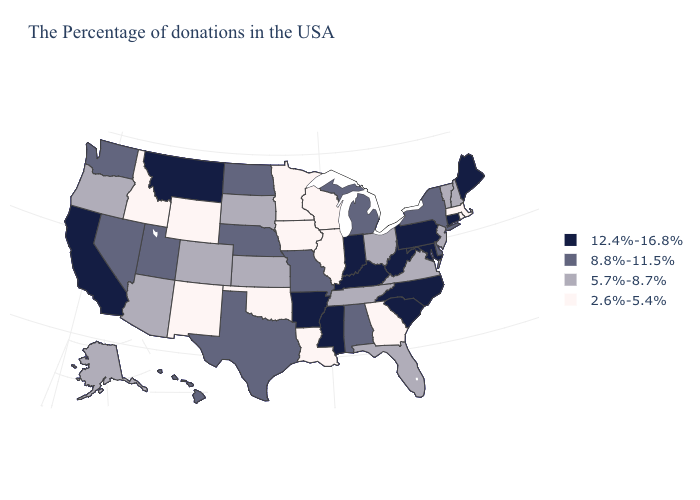Does Vermont have the same value as New Jersey?
Keep it brief. Yes. Among the states that border Colorado , does Kansas have the lowest value?
Quick response, please. No. Does New York have the lowest value in the Northeast?
Write a very short answer. No. Does the first symbol in the legend represent the smallest category?
Concise answer only. No. What is the value of Maine?
Answer briefly. 12.4%-16.8%. Which states have the lowest value in the USA?
Write a very short answer. Massachusetts, Rhode Island, Georgia, Wisconsin, Illinois, Louisiana, Minnesota, Iowa, Oklahoma, Wyoming, New Mexico, Idaho. Among the states that border Wisconsin , does Michigan have the highest value?
Concise answer only. Yes. Name the states that have a value in the range 12.4%-16.8%?
Concise answer only. Maine, Connecticut, Maryland, Pennsylvania, North Carolina, South Carolina, West Virginia, Kentucky, Indiana, Mississippi, Arkansas, Montana, California. Which states have the lowest value in the West?
Answer briefly. Wyoming, New Mexico, Idaho. Which states have the lowest value in the USA?
Concise answer only. Massachusetts, Rhode Island, Georgia, Wisconsin, Illinois, Louisiana, Minnesota, Iowa, Oklahoma, Wyoming, New Mexico, Idaho. What is the value of Texas?
Concise answer only. 8.8%-11.5%. Among the states that border Arkansas , which have the lowest value?
Short answer required. Louisiana, Oklahoma. What is the highest value in the West ?
Concise answer only. 12.4%-16.8%. What is the lowest value in the USA?
Answer briefly. 2.6%-5.4%. Does Louisiana have the lowest value in the South?
Give a very brief answer. Yes. 